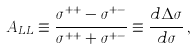Convert formula to latex. <formula><loc_0><loc_0><loc_500><loc_500>A _ { L L } \equiv \frac { \sigma ^ { + + } - \sigma ^ { + - } } { \sigma ^ { + + } + \sigma ^ { + - } } \equiv \frac { d \Delta \sigma } { d \sigma } \, ,</formula> 